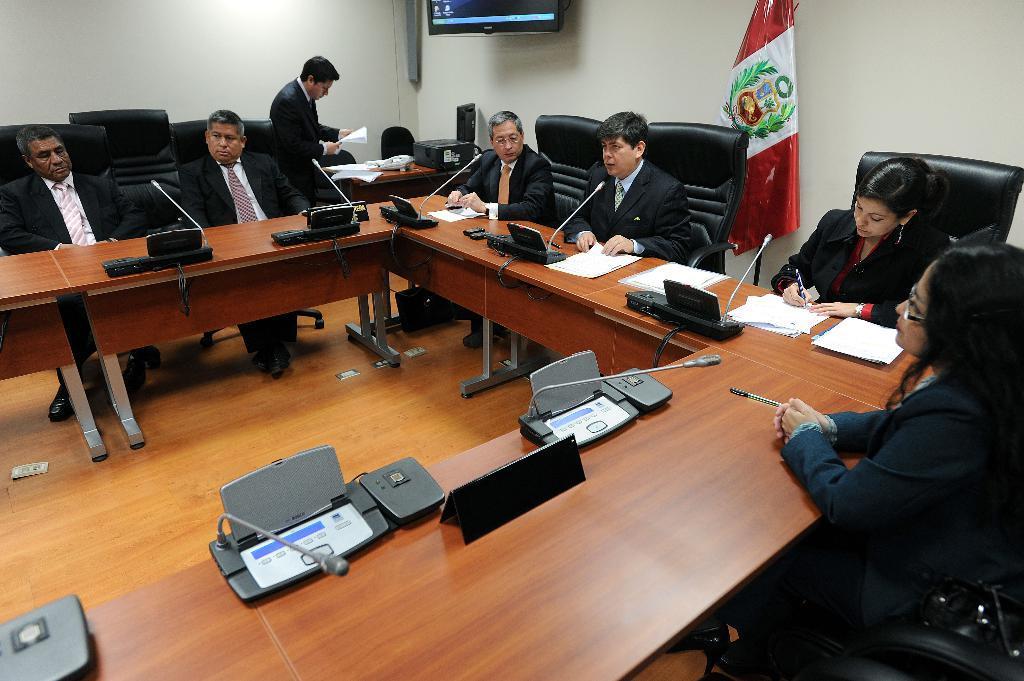Describe this image in one or two sentences. In this image we can see people sitting on the chair and we can also see wooden benches, electronic gadgets, the flag and the wall. 